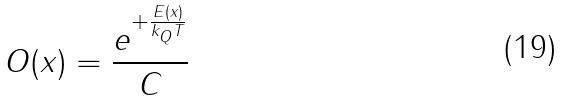Convert formula to latex. <formula><loc_0><loc_0><loc_500><loc_500>O ( x ) = \frac { e ^ { + \frac { E ( x ) } { k _ { Q } T } } } { C }</formula> 